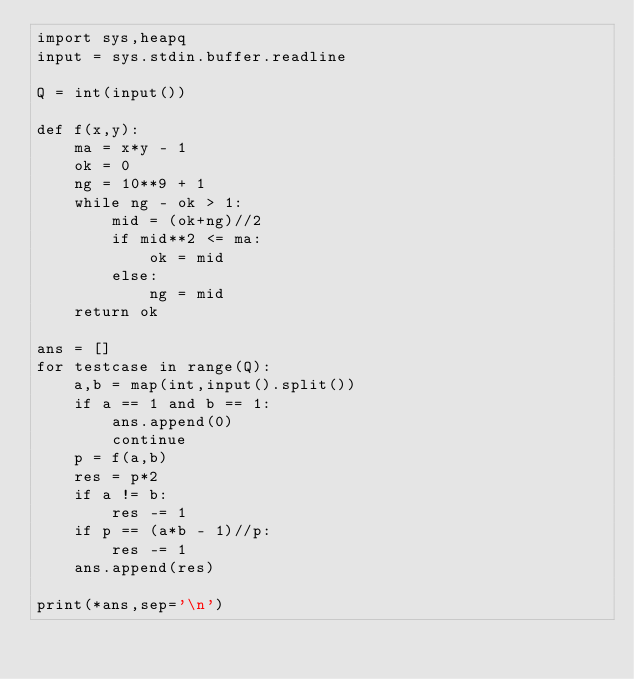Convert code to text. <code><loc_0><loc_0><loc_500><loc_500><_Python_>import sys,heapq
input = sys.stdin.buffer.readline

Q = int(input())

def f(x,y):
    ma = x*y - 1
    ok = 0
    ng = 10**9 + 1
    while ng - ok > 1:
        mid = (ok+ng)//2
        if mid**2 <= ma:
            ok = mid
        else:
            ng = mid
    return ok

ans = []
for testcase in range(Q):
    a,b = map(int,input().split())
    if a == 1 and b == 1:
        ans.append(0)
        continue
    p = f(a,b)
    res = p*2
    if a != b:
        res -= 1
    if p == (a*b - 1)//p:
        res -= 1
    ans.append(res)

print(*ans,sep='\n')</code> 